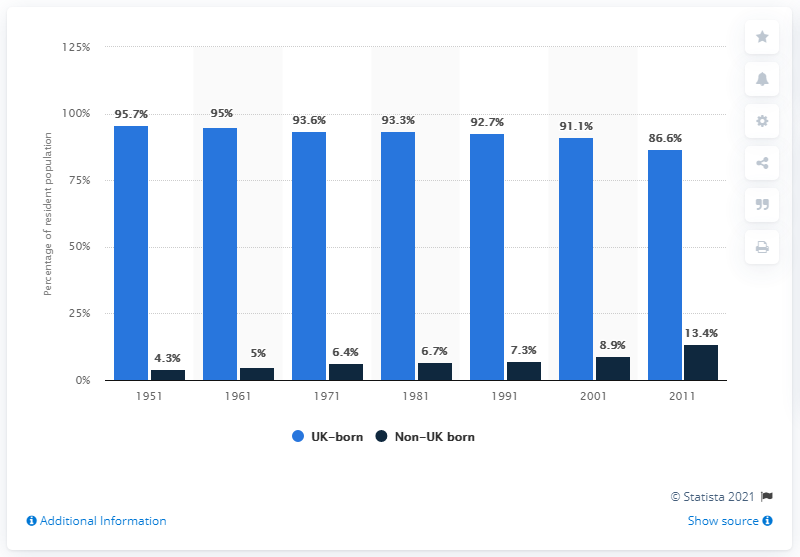Point out several critical features in this image. The population of the UK was divided into residents born outside of the UK in the year 1951. 